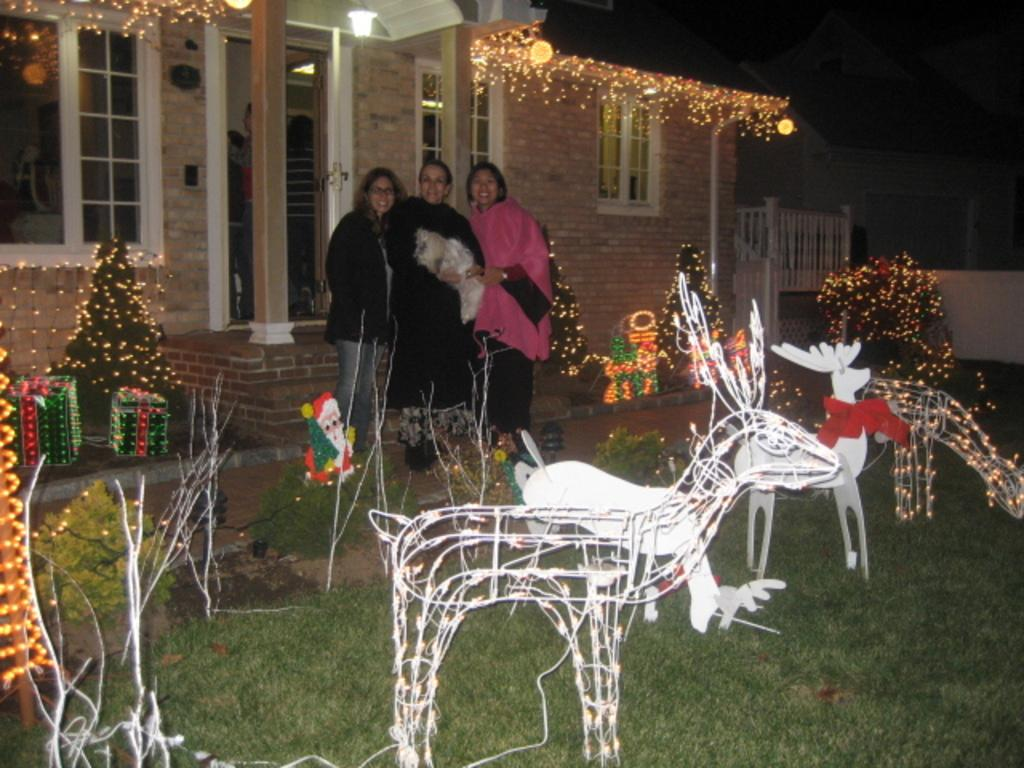How many women are in the image? There are three women in the image. What is the facial expression of the women? The women are smiling. What can be seen in the image besides the women? There is decoration, grass, a house, and lights visible in the image. What is the color of the background in the image? The background of the image is dark. Are there any farm animals visible in the image? There are no farm animals present in the image. Is the grass covered in snow in the image? There is no snow visible in the image; the grass is not covered in snow. 